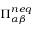<formula> <loc_0><loc_0><loc_500><loc_500>\Pi _ { \alpha \beta } ^ { n e q }</formula> 